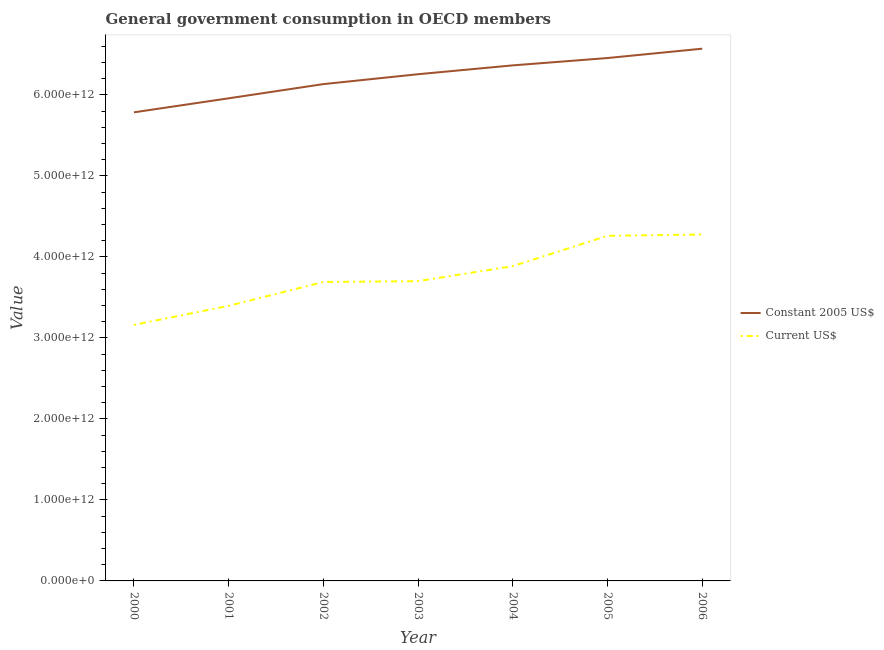What is the value consumed in current us$ in 2000?
Provide a short and direct response. 3.16e+12. Across all years, what is the maximum value consumed in current us$?
Provide a short and direct response. 4.28e+12. Across all years, what is the minimum value consumed in current us$?
Provide a short and direct response. 3.16e+12. In which year was the value consumed in constant 2005 us$ maximum?
Ensure brevity in your answer.  2006. What is the total value consumed in constant 2005 us$ in the graph?
Give a very brief answer. 4.35e+13. What is the difference between the value consumed in constant 2005 us$ in 2004 and that in 2006?
Your response must be concise. -2.06e+11. What is the difference between the value consumed in constant 2005 us$ in 2004 and the value consumed in current us$ in 2000?
Your answer should be compact. 3.20e+12. What is the average value consumed in current us$ per year?
Offer a terse response. 3.77e+12. In the year 2004, what is the difference between the value consumed in current us$ and value consumed in constant 2005 us$?
Your response must be concise. -2.48e+12. What is the ratio of the value consumed in current us$ in 2001 to that in 2003?
Provide a succinct answer. 0.92. Is the difference between the value consumed in constant 2005 us$ in 2002 and 2006 greater than the difference between the value consumed in current us$ in 2002 and 2006?
Ensure brevity in your answer.  Yes. What is the difference between the highest and the second highest value consumed in current us$?
Ensure brevity in your answer.  1.57e+1. What is the difference between the highest and the lowest value consumed in constant 2005 us$?
Keep it short and to the point. 7.85e+11. In how many years, is the value consumed in constant 2005 us$ greater than the average value consumed in constant 2005 us$ taken over all years?
Your answer should be very brief. 4. How many lines are there?
Ensure brevity in your answer.  2. What is the difference between two consecutive major ticks on the Y-axis?
Your response must be concise. 1.00e+12. Does the graph contain any zero values?
Your response must be concise. No. Where does the legend appear in the graph?
Provide a succinct answer. Center right. How many legend labels are there?
Offer a very short reply. 2. How are the legend labels stacked?
Provide a succinct answer. Vertical. What is the title of the graph?
Your answer should be compact. General government consumption in OECD members. Does "Electricity and heat production" appear as one of the legend labels in the graph?
Offer a very short reply. No. What is the label or title of the X-axis?
Your answer should be very brief. Year. What is the label or title of the Y-axis?
Keep it short and to the point. Value. What is the Value of Constant 2005 US$ in 2000?
Ensure brevity in your answer.  5.78e+12. What is the Value in Current US$ in 2000?
Offer a terse response. 3.16e+12. What is the Value of Constant 2005 US$ in 2001?
Offer a terse response. 5.96e+12. What is the Value of Current US$ in 2001?
Offer a terse response. 3.40e+12. What is the Value of Constant 2005 US$ in 2002?
Your response must be concise. 6.13e+12. What is the Value in Current US$ in 2002?
Your response must be concise. 3.69e+12. What is the Value of Constant 2005 US$ in 2003?
Give a very brief answer. 6.25e+12. What is the Value of Current US$ in 2003?
Ensure brevity in your answer.  3.70e+12. What is the Value of Constant 2005 US$ in 2004?
Your answer should be very brief. 6.36e+12. What is the Value in Current US$ in 2004?
Provide a succinct answer. 3.89e+12. What is the Value in Constant 2005 US$ in 2005?
Your answer should be very brief. 6.45e+12. What is the Value in Current US$ in 2005?
Your answer should be very brief. 4.26e+12. What is the Value of Constant 2005 US$ in 2006?
Provide a short and direct response. 6.57e+12. What is the Value in Current US$ in 2006?
Ensure brevity in your answer.  4.28e+12. Across all years, what is the maximum Value in Constant 2005 US$?
Provide a succinct answer. 6.57e+12. Across all years, what is the maximum Value in Current US$?
Provide a short and direct response. 4.28e+12. Across all years, what is the minimum Value in Constant 2005 US$?
Make the answer very short. 5.78e+12. Across all years, what is the minimum Value in Current US$?
Ensure brevity in your answer.  3.16e+12. What is the total Value in Constant 2005 US$ in the graph?
Provide a short and direct response. 4.35e+13. What is the total Value of Current US$ in the graph?
Offer a terse response. 2.64e+13. What is the difference between the Value of Constant 2005 US$ in 2000 and that in 2001?
Your answer should be very brief. -1.73e+11. What is the difference between the Value in Current US$ in 2000 and that in 2001?
Your answer should be compact. -2.35e+11. What is the difference between the Value in Constant 2005 US$ in 2000 and that in 2002?
Offer a terse response. -3.48e+11. What is the difference between the Value in Current US$ in 2000 and that in 2002?
Your response must be concise. -5.30e+11. What is the difference between the Value of Constant 2005 US$ in 2000 and that in 2003?
Your answer should be very brief. -4.70e+11. What is the difference between the Value in Current US$ in 2000 and that in 2003?
Provide a succinct answer. -5.40e+11. What is the difference between the Value in Constant 2005 US$ in 2000 and that in 2004?
Keep it short and to the point. -5.79e+11. What is the difference between the Value of Current US$ in 2000 and that in 2004?
Offer a terse response. -7.25e+11. What is the difference between the Value of Constant 2005 US$ in 2000 and that in 2005?
Your answer should be compact. -6.70e+11. What is the difference between the Value of Current US$ in 2000 and that in 2005?
Keep it short and to the point. -1.10e+12. What is the difference between the Value in Constant 2005 US$ in 2000 and that in 2006?
Your answer should be compact. -7.85e+11. What is the difference between the Value of Current US$ in 2000 and that in 2006?
Offer a terse response. -1.12e+12. What is the difference between the Value in Constant 2005 US$ in 2001 and that in 2002?
Your response must be concise. -1.75e+11. What is the difference between the Value in Current US$ in 2001 and that in 2002?
Keep it short and to the point. -2.94e+11. What is the difference between the Value in Constant 2005 US$ in 2001 and that in 2003?
Provide a succinct answer. -2.97e+11. What is the difference between the Value of Current US$ in 2001 and that in 2003?
Provide a short and direct response. -3.04e+11. What is the difference between the Value in Constant 2005 US$ in 2001 and that in 2004?
Your response must be concise. -4.07e+11. What is the difference between the Value of Current US$ in 2001 and that in 2004?
Keep it short and to the point. -4.90e+11. What is the difference between the Value in Constant 2005 US$ in 2001 and that in 2005?
Keep it short and to the point. -4.97e+11. What is the difference between the Value in Current US$ in 2001 and that in 2005?
Keep it short and to the point. -8.64e+11. What is the difference between the Value in Constant 2005 US$ in 2001 and that in 2006?
Your answer should be very brief. -6.12e+11. What is the difference between the Value in Current US$ in 2001 and that in 2006?
Provide a short and direct response. -8.80e+11. What is the difference between the Value in Constant 2005 US$ in 2002 and that in 2003?
Give a very brief answer. -1.22e+11. What is the difference between the Value in Current US$ in 2002 and that in 2003?
Your answer should be compact. -1.01e+1. What is the difference between the Value in Constant 2005 US$ in 2002 and that in 2004?
Give a very brief answer. -2.31e+11. What is the difference between the Value of Current US$ in 2002 and that in 2004?
Provide a short and direct response. -1.95e+11. What is the difference between the Value in Constant 2005 US$ in 2002 and that in 2005?
Give a very brief answer. -3.22e+11. What is the difference between the Value of Current US$ in 2002 and that in 2005?
Your answer should be compact. -5.70e+11. What is the difference between the Value in Constant 2005 US$ in 2002 and that in 2006?
Keep it short and to the point. -4.37e+11. What is the difference between the Value in Current US$ in 2002 and that in 2006?
Your answer should be very brief. -5.86e+11. What is the difference between the Value in Constant 2005 US$ in 2003 and that in 2004?
Give a very brief answer. -1.09e+11. What is the difference between the Value in Current US$ in 2003 and that in 2004?
Give a very brief answer. -1.85e+11. What is the difference between the Value in Constant 2005 US$ in 2003 and that in 2005?
Provide a short and direct response. -2.00e+11. What is the difference between the Value of Current US$ in 2003 and that in 2005?
Keep it short and to the point. -5.60e+11. What is the difference between the Value of Constant 2005 US$ in 2003 and that in 2006?
Provide a succinct answer. -3.15e+11. What is the difference between the Value in Current US$ in 2003 and that in 2006?
Offer a terse response. -5.76e+11. What is the difference between the Value in Constant 2005 US$ in 2004 and that in 2005?
Provide a succinct answer. -9.06e+1. What is the difference between the Value in Current US$ in 2004 and that in 2005?
Your answer should be compact. -3.75e+11. What is the difference between the Value in Constant 2005 US$ in 2004 and that in 2006?
Give a very brief answer. -2.06e+11. What is the difference between the Value in Current US$ in 2004 and that in 2006?
Keep it short and to the point. -3.90e+11. What is the difference between the Value in Constant 2005 US$ in 2005 and that in 2006?
Keep it short and to the point. -1.15e+11. What is the difference between the Value in Current US$ in 2005 and that in 2006?
Your answer should be very brief. -1.57e+1. What is the difference between the Value in Constant 2005 US$ in 2000 and the Value in Current US$ in 2001?
Your answer should be very brief. 2.39e+12. What is the difference between the Value of Constant 2005 US$ in 2000 and the Value of Current US$ in 2002?
Keep it short and to the point. 2.09e+12. What is the difference between the Value in Constant 2005 US$ in 2000 and the Value in Current US$ in 2003?
Provide a short and direct response. 2.08e+12. What is the difference between the Value of Constant 2005 US$ in 2000 and the Value of Current US$ in 2004?
Make the answer very short. 1.90e+12. What is the difference between the Value of Constant 2005 US$ in 2000 and the Value of Current US$ in 2005?
Make the answer very short. 1.52e+12. What is the difference between the Value of Constant 2005 US$ in 2000 and the Value of Current US$ in 2006?
Make the answer very short. 1.51e+12. What is the difference between the Value of Constant 2005 US$ in 2001 and the Value of Current US$ in 2002?
Make the answer very short. 2.27e+12. What is the difference between the Value in Constant 2005 US$ in 2001 and the Value in Current US$ in 2003?
Give a very brief answer. 2.26e+12. What is the difference between the Value of Constant 2005 US$ in 2001 and the Value of Current US$ in 2004?
Offer a very short reply. 2.07e+12. What is the difference between the Value in Constant 2005 US$ in 2001 and the Value in Current US$ in 2005?
Make the answer very short. 1.70e+12. What is the difference between the Value in Constant 2005 US$ in 2001 and the Value in Current US$ in 2006?
Your response must be concise. 1.68e+12. What is the difference between the Value in Constant 2005 US$ in 2002 and the Value in Current US$ in 2003?
Keep it short and to the point. 2.43e+12. What is the difference between the Value of Constant 2005 US$ in 2002 and the Value of Current US$ in 2004?
Offer a terse response. 2.25e+12. What is the difference between the Value of Constant 2005 US$ in 2002 and the Value of Current US$ in 2005?
Keep it short and to the point. 1.87e+12. What is the difference between the Value of Constant 2005 US$ in 2002 and the Value of Current US$ in 2006?
Ensure brevity in your answer.  1.86e+12. What is the difference between the Value in Constant 2005 US$ in 2003 and the Value in Current US$ in 2004?
Your answer should be very brief. 2.37e+12. What is the difference between the Value in Constant 2005 US$ in 2003 and the Value in Current US$ in 2005?
Provide a short and direct response. 1.99e+12. What is the difference between the Value in Constant 2005 US$ in 2003 and the Value in Current US$ in 2006?
Provide a short and direct response. 1.98e+12. What is the difference between the Value in Constant 2005 US$ in 2004 and the Value in Current US$ in 2005?
Provide a succinct answer. 2.10e+12. What is the difference between the Value of Constant 2005 US$ in 2004 and the Value of Current US$ in 2006?
Give a very brief answer. 2.09e+12. What is the difference between the Value of Constant 2005 US$ in 2005 and the Value of Current US$ in 2006?
Your answer should be very brief. 2.18e+12. What is the average Value in Constant 2005 US$ per year?
Give a very brief answer. 6.22e+12. What is the average Value in Current US$ per year?
Provide a succinct answer. 3.77e+12. In the year 2000, what is the difference between the Value in Constant 2005 US$ and Value in Current US$?
Make the answer very short. 2.62e+12. In the year 2001, what is the difference between the Value of Constant 2005 US$ and Value of Current US$?
Your response must be concise. 2.56e+12. In the year 2002, what is the difference between the Value of Constant 2005 US$ and Value of Current US$?
Offer a terse response. 2.44e+12. In the year 2003, what is the difference between the Value in Constant 2005 US$ and Value in Current US$?
Make the answer very short. 2.55e+12. In the year 2004, what is the difference between the Value of Constant 2005 US$ and Value of Current US$?
Offer a very short reply. 2.48e+12. In the year 2005, what is the difference between the Value of Constant 2005 US$ and Value of Current US$?
Provide a short and direct response. 2.19e+12. In the year 2006, what is the difference between the Value of Constant 2005 US$ and Value of Current US$?
Your answer should be very brief. 2.29e+12. What is the ratio of the Value of Current US$ in 2000 to that in 2001?
Your answer should be compact. 0.93. What is the ratio of the Value in Constant 2005 US$ in 2000 to that in 2002?
Offer a terse response. 0.94. What is the ratio of the Value in Current US$ in 2000 to that in 2002?
Give a very brief answer. 0.86. What is the ratio of the Value in Constant 2005 US$ in 2000 to that in 2003?
Offer a very short reply. 0.92. What is the ratio of the Value of Current US$ in 2000 to that in 2003?
Provide a short and direct response. 0.85. What is the ratio of the Value in Constant 2005 US$ in 2000 to that in 2004?
Provide a succinct answer. 0.91. What is the ratio of the Value in Current US$ in 2000 to that in 2004?
Give a very brief answer. 0.81. What is the ratio of the Value in Constant 2005 US$ in 2000 to that in 2005?
Offer a very short reply. 0.9. What is the ratio of the Value in Current US$ in 2000 to that in 2005?
Provide a succinct answer. 0.74. What is the ratio of the Value of Constant 2005 US$ in 2000 to that in 2006?
Keep it short and to the point. 0.88. What is the ratio of the Value in Current US$ in 2000 to that in 2006?
Your answer should be compact. 0.74. What is the ratio of the Value in Constant 2005 US$ in 2001 to that in 2002?
Keep it short and to the point. 0.97. What is the ratio of the Value of Current US$ in 2001 to that in 2002?
Make the answer very short. 0.92. What is the ratio of the Value in Constant 2005 US$ in 2001 to that in 2003?
Give a very brief answer. 0.95. What is the ratio of the Value of Current US$ in 2001 to that in 2003?
Keep it short and to the point. 0.92. What is the ratio of the Value of Constant 2005 US$ in 2001 to that in 2004?
Provide a succinct answer. 0.94. What is the ratio of the Value in Current US$ in 2001 to that in 2004?
Make the answer very short. 0.87. What is the ratio of the Value of Constant 2005 US$ in 2001 to that in 2005?
Ensure brevity in your answer.  0.92. What is the ratio of the Value in Current US$ in 2001 to that in 2005?
Your answer should be compact. 0.8. What is the ratio of the Value of Constant 2005 US$ in 2001 to that in 2006?
Make the answer very short. 0.91. What is the ratio of the Value of Current US$ in 2001 to that in 2006?
Offer a very short reply. 0.79. What is the ratio of the Value of Constant 2005 US$ in 2002 to that in 2003?
Ensure brevity in your answer.  0.98. What is the ratio of the Value of Constant 2005 US$ in 2002 to that in 2004?
Your answer should be very brief. 0.96. What is the ratio of the Value of Current US$ in 2002 to that in 2004?
Your response must be concise. 0.95. What is the ratio of the Value in Constant 2005 US$ in 2002 to that in 2005?
Give a very brief answer. 0.95. What is the ratio of the Value of Current US$ in 2002 to that in 2005?
Keep it short and to the point. 0.87. What is the ratio of the Value of Constant 2005 US$ in 2002 to that in 2006?
Provide a short and direct response. 0.93. What is the ratio of the Value in Current US$ in 2002 to that in 2006?
Provide a short and direct response. 0.86. What is the ratio of the Value in Constant 2005 US$ in 2003 to that in 2004?
Your response must be concise. 0.98. What is the ratio of the Value of Current US$ in 2003 to that in 2004?
Your answer should be very brief. 0.95. What is the ratio of the Value in Constant 2005 US$ in 2003 to that in 2005?
Your answer should be compact. 0.97. What is the ratio of the Value in Current US$ in 2003 to that in 2005?
Ensure brevity in your answer.  0.87. What is the ratio of the Value of Current US$ in 2003 to that in 2006?
Offer a terse response. 0.87. What is the ratio of the Value of Current US$ in 2004 to that in 2005?
Ensure brevity in your answer.  0.91. What is the ratio of the Value in Constant 2005 US$ in 2004 to that in 2006?
Your answer should be very brief. 0.97. What is the ratio of the Value in Current US$ in 2004 to that in 2006?
Your response must be concise. 0.91. What is the ratio of the Value of Constant 2005 US$ in 2005 to that in 2006?
Make the answer very short. 0.98. What is the difference between the highest and the second highest Value in Constant 2005 US$?
Give a very brief answer. 1.15e+11. What is the difference between the highest and the second highest Value in Current US$?
Offer a very short reply. 1.57e+1. What is the difference between the highest and the lowest Value of Constant 2005 US$?
Offer a terse response. 7.85e+11. What is the difference between the highest and the lowest Value of Current US$?
Give a very brief answer. 1.12e+12. 